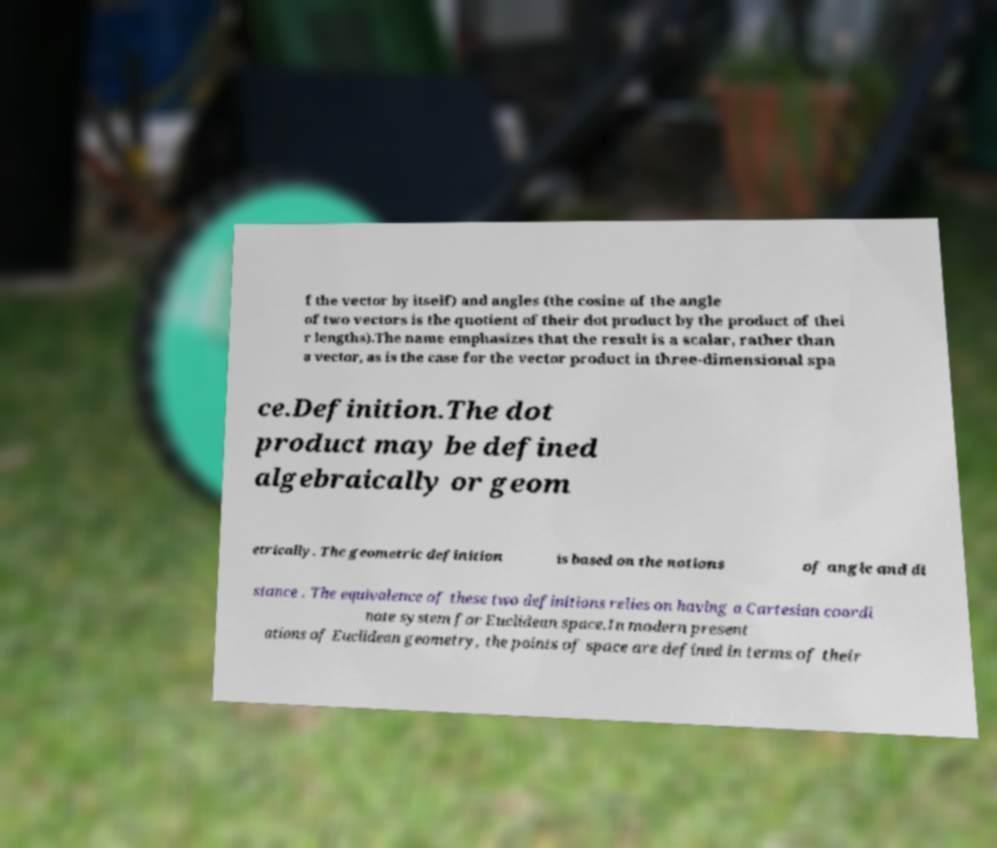There's text embedded in this image that I need extracted. Can you transcribe it verbatim? f the vector by itself) and angles (the cosine of the angle of two vectors is the quotient of their dot product by the product of thei r lengths).The name emphasizes that the result is a scalar, rather than a vector, as is the case for the vector product in three-dimensional spa ce.Definition.The dot product may be defined algebraically or geom etrically. The geometric definition is based on the notions of angle and di stance . The equivalence of these two definitions relies on having a Cartesian coordi nate system for Euclidean space.In modern present ations of Euclidean geometry, the points of space are defined in terms of their 